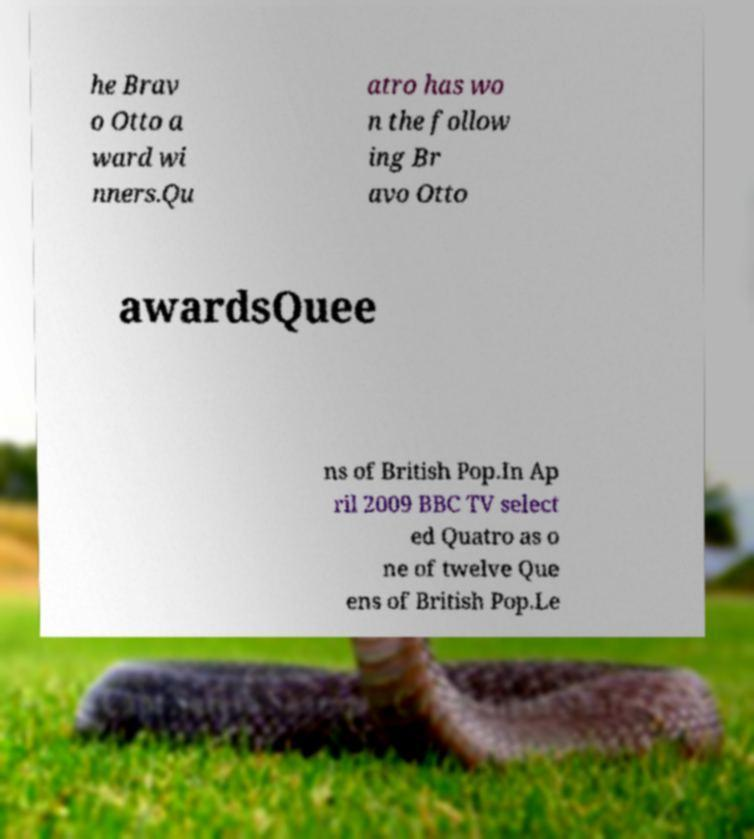Please identify and transcribe the text found in this image. he Brav o Otto a ward wi nners.Qu atro has wo n the follow ing Br avo Otto awardsQuee ns of British Pop.In Ap ril 2009 BBC TV select ed Quatro as o ne of twelve Que ens of British Pop.Le 